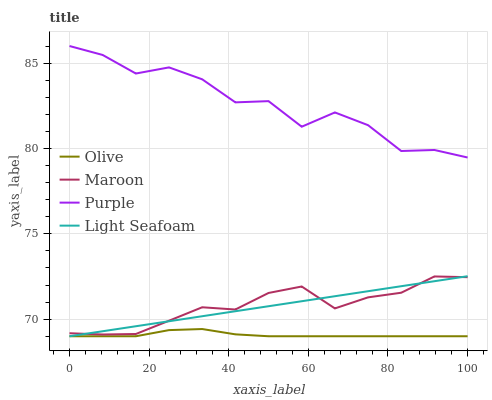Does Olive have the minimum area under the curve?
Answer yes or no. Yes. Does Purple have the maximum area under the curve?
Answer yes or no. Yes. Does Light Seafoam have the minimum area under the curve?
Answer yes or no. No. Does Light Seafoam have the maximum area under the curve?
Answer yes or no. No. Is Light Seafoam the smoothest?
Answer yes or no. Yes. Is Purple the roughest?
Answer yes or no. Yes. Is Purple the smoothest?
Answer yes or no. No. Is Light Seafoam the roughest?
Answer yes or no. No. Does Purple have the lowest value?
Answer yes or no. No. Does Light Seafoam have the highest value?
Answer yes or no. No. Is Olive less than Purple?
Answer yes or no. Yes. Is Purple greater than Olive?
Answer yes or no. Yes. Does Olive intersect Purple?
Answer yes or no. No. 